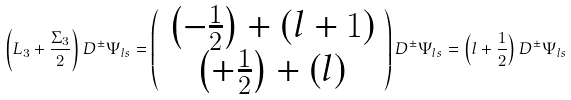<formula> <loc_0><loc_0><loc_500><loc_500>\left ( L _ { 3 } + \frac { \Sigma _ { 3 } } { 2 } \right ) D ^ { \pm } \Psi _ { l s } = \left ( \begin{array} { c } \left ( - \frac { 1 } { 2 } \right ) + \left ( l + 1 \right ) \\ \left ( + \frac { 1 } { 2 } \right ) + \left ( l \right ) \end{array} \right ) D ^ { \pm } \Psi _ { l s } = \left ( l + \frac { 1 } { 2 } \right ) D ^ { \pm } \Psi _ { l s }</formula> 